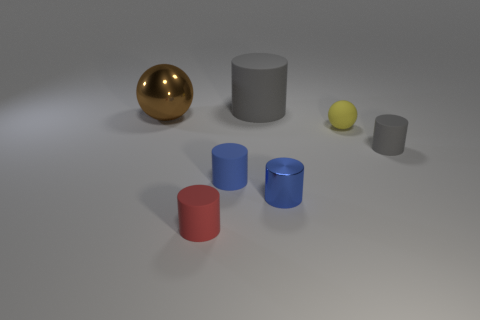How many things are tiny cylinders that are right of the big gray cylinder or big cyan metallic cylinders?
Make the answer very short. 2. There is a gray cylinder on the right side of the gray object that is behind the brown metal sphere; are there any blue matte objects behind it?
Offer a very short reply. No. What number of brown blocks are there?
Your answer should be very brief. 0. What number of objects are rubber things right of the red object or large objects that are left of the tiny red matte thing?
Provide a short and direct response. 5. There is a gray rubber thing that is behind the yellow ball; does it have the same size as the small matte ball?
Your response must be concise. No. What size is the red matte thing that is the same shape as the blue metal object?
Provide a succinct answer. Small. There is a thing that is the same size as the metal ball; what material is it?
Provide a short and direct response. Rubber. There is a big gray object that is the same shape as the tiny blue rubber object; what material is it?
Provide a succinct answer. Rubber. What number of other things are the same size as the brown object?
Provide a succinct answer. 1. There is a cylinder that is the same color as the small metallic thing; what is its size?
Your response must be concise. Small. 